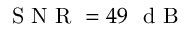<formula> <loc_0><loc_0><loc_500><loc_500>S N R = 4 9 \ d B</formula> 